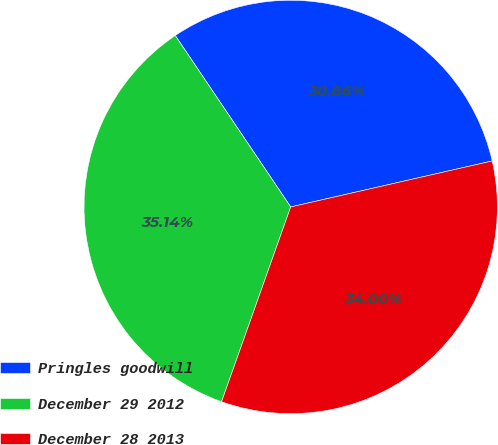Convert chart to OTSL. <chart><loc_0><loc_0><loc_500><loc_500><pie_chart><fcel>Pringles goodwill<fcel>December 29 2012<fcel>December 28 2013<nl><fcel>30.86%<fcel>35.14%<fcel>34.0%<nl></chart> 